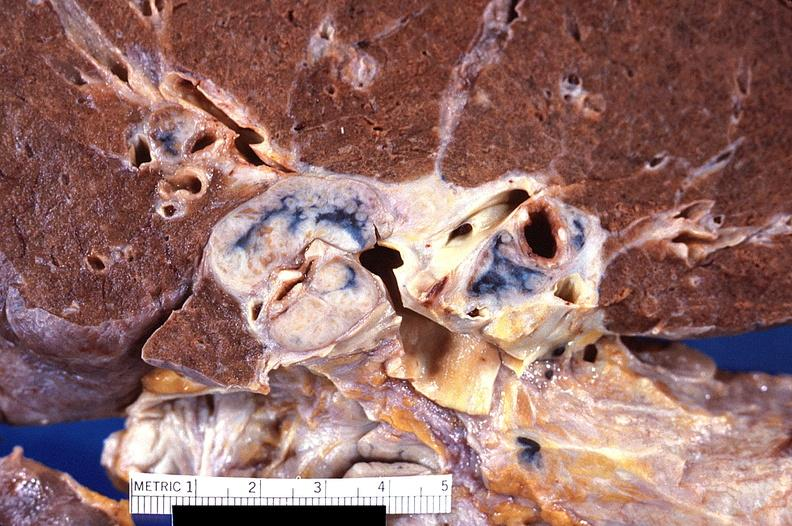s respiratory present?
Answer the question using a single word or phrase. Yes 